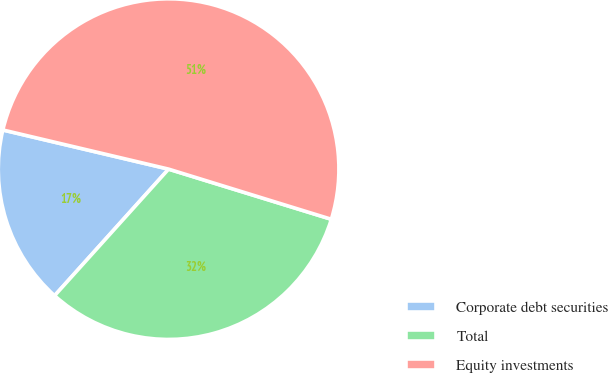<chart> <loc_0><loc_0><loc_500><loc_500><pie_chart><fcel>Corporate debt securities<fcel>Total<fcel>Equity investments<nl><fcel>17.02%<fcel>31.91%<fcel>51.06%<nl></chart> 